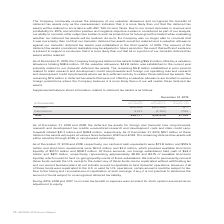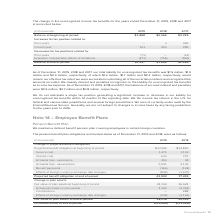According to Adtran's financial document, What was the company's total liability for unrecognized tax benefits in 2019? According to the financial document, $1.5 million (in millions). The relevant text states: "total liability for unrecognized tax benefits was $1.5 million, $1.9 million and $2.4 million, respectively, of which $1.4 million, $1.7 million and $2.2 million,..." Also, What does the table show? change in the unrecognized income tax benefits for the years ended December 31, 2019, 2018 and 2017. The document states: "The change in the unrecognized income tax benefits for the years ended December 31, 2019, 2018 and 2017 is reconciled below:..." Also, What is the  Balance at beginning of period for 2019? According to the financial document, $1,868 (in thousands). The relevant text states: "Balance at beginning of period $1,868 $2,366 $2,226..." Also, can you calculate: What was the change in the balance at the beginning of period between 2018 and 2019? Based on the calculation: $1,868-$2,366, the result is -498 (in thousands). This is based on the information: "Balance at beginning of period $1,868 $2,366 $2,226 Balance at beginning of period $1,868 $2,366 $2,226..." The key data points involved are: 1,868, 2,366. Also, can you calculate: What was the change in the balance at the end of period between 2018 and 2019? Based on the calculation: $1,487-$1,868, the result is -381 (in thousands). This is based on the information: "Balance at end of period $1,487 $1,868 $2,366 Balance at end of period $1,487 $1,868 $2,366..." The key data points involved are: 1,487, 1,868. Also, can you calculate: What was the percentage change in the expiration of applicable statute of limitations between 2017 and 2018? To answer this question, I need to perform calculations using the financial data. The calculation is: (-755-(-596))/-596, which equals 26.68 (percentage). This is based on the information: "of applicable statute of limitations (471) (755) (596) ation of applicable statute of limitations (471) (755) (596)..." The key data points involved are: 596, 755. 